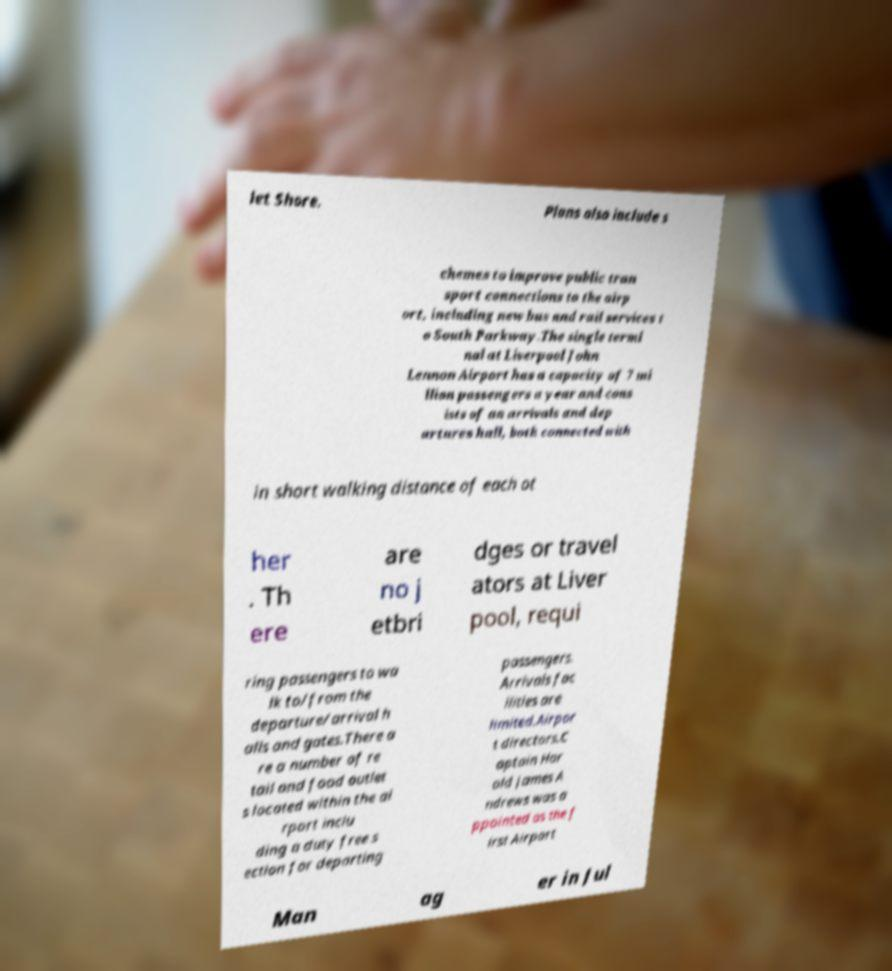There's text embedded in this image that I need extracted. Can you transcribe it verbatim? let Shore. Plans also include s chemes to improve public tran sport connections to the airp ort, including new bus and rail services t o South Parkway.The single termi nal at Liverpool John Lennon Airport has a capacity of 7 mi llion passengers a year and cons ists of an arrivals and dep artures hall, both connected with in short walking distance of each ot her . Th ere are no j etbri dges or travel ators at Liver pool, requi ring passengers to wa lk to/from the departure/arrival h alls and gates.There a re a number of re tail and food outlet s located within the ai rport inclu ding a duty free s ection for departing passengers. Arrivals fac ilities are limited.Airpor t directors.C aptain Har old James A ndrews was a ppointed as the f irst Airport Man ag er in Jul 